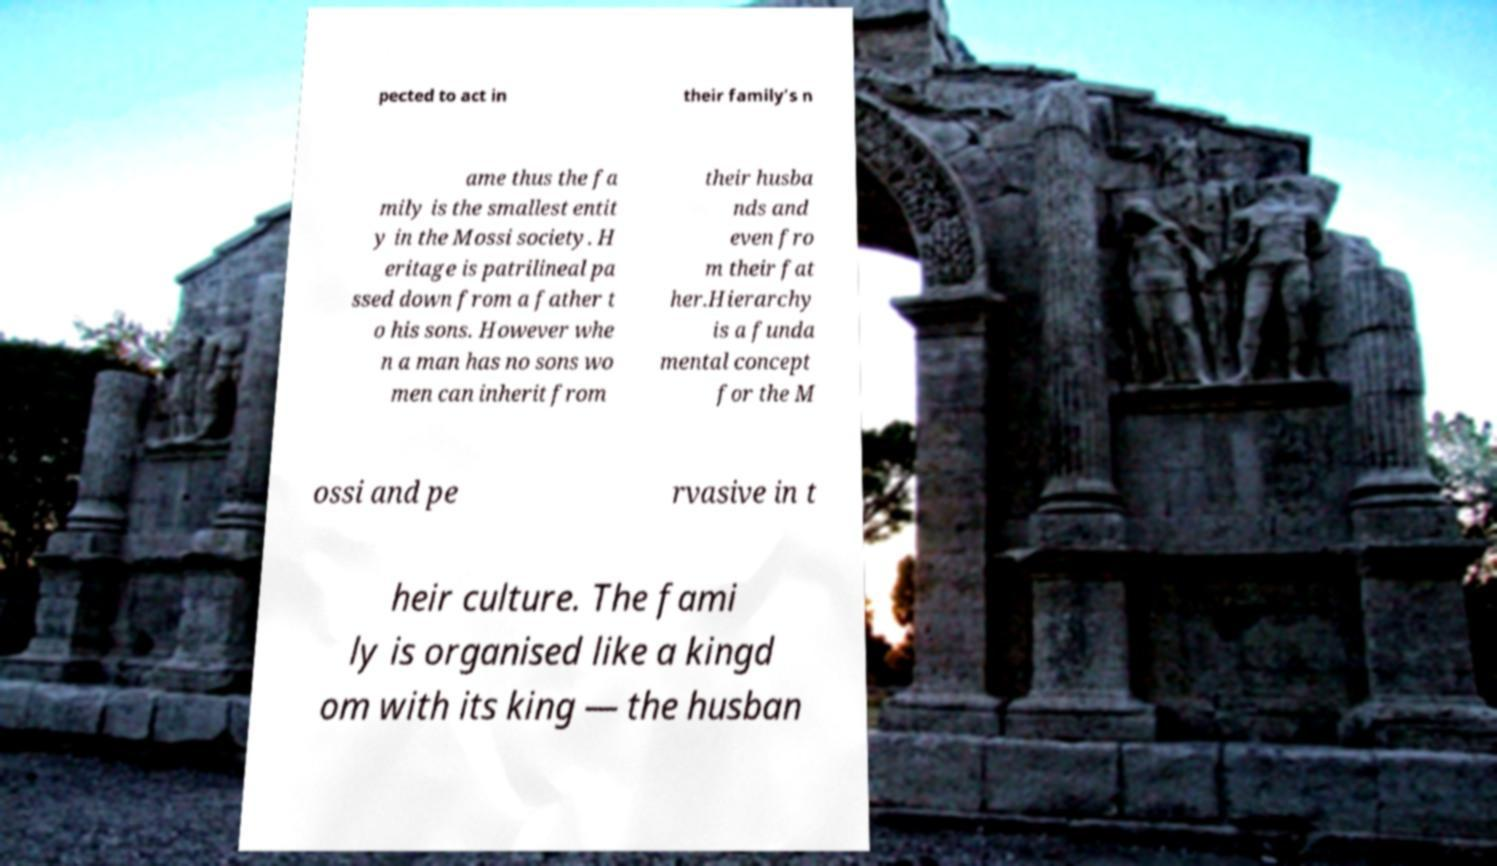What messages or text are displayed in this image? I need them in a readable, typed format. pected to act in their family's n ame thus the fa mily is the smallest entit y in the Mossi society. H eritage is patrilineal pa ssed down from a father t o his sons. However whe n a man has no sons wo men can inherit from their husba nds and even fro m their fat her.Hierarchy is a funda mental concept for the M ossi and pe rvasive in t heir culture. The fami ly is organised like a kingd om with its king — the husban 